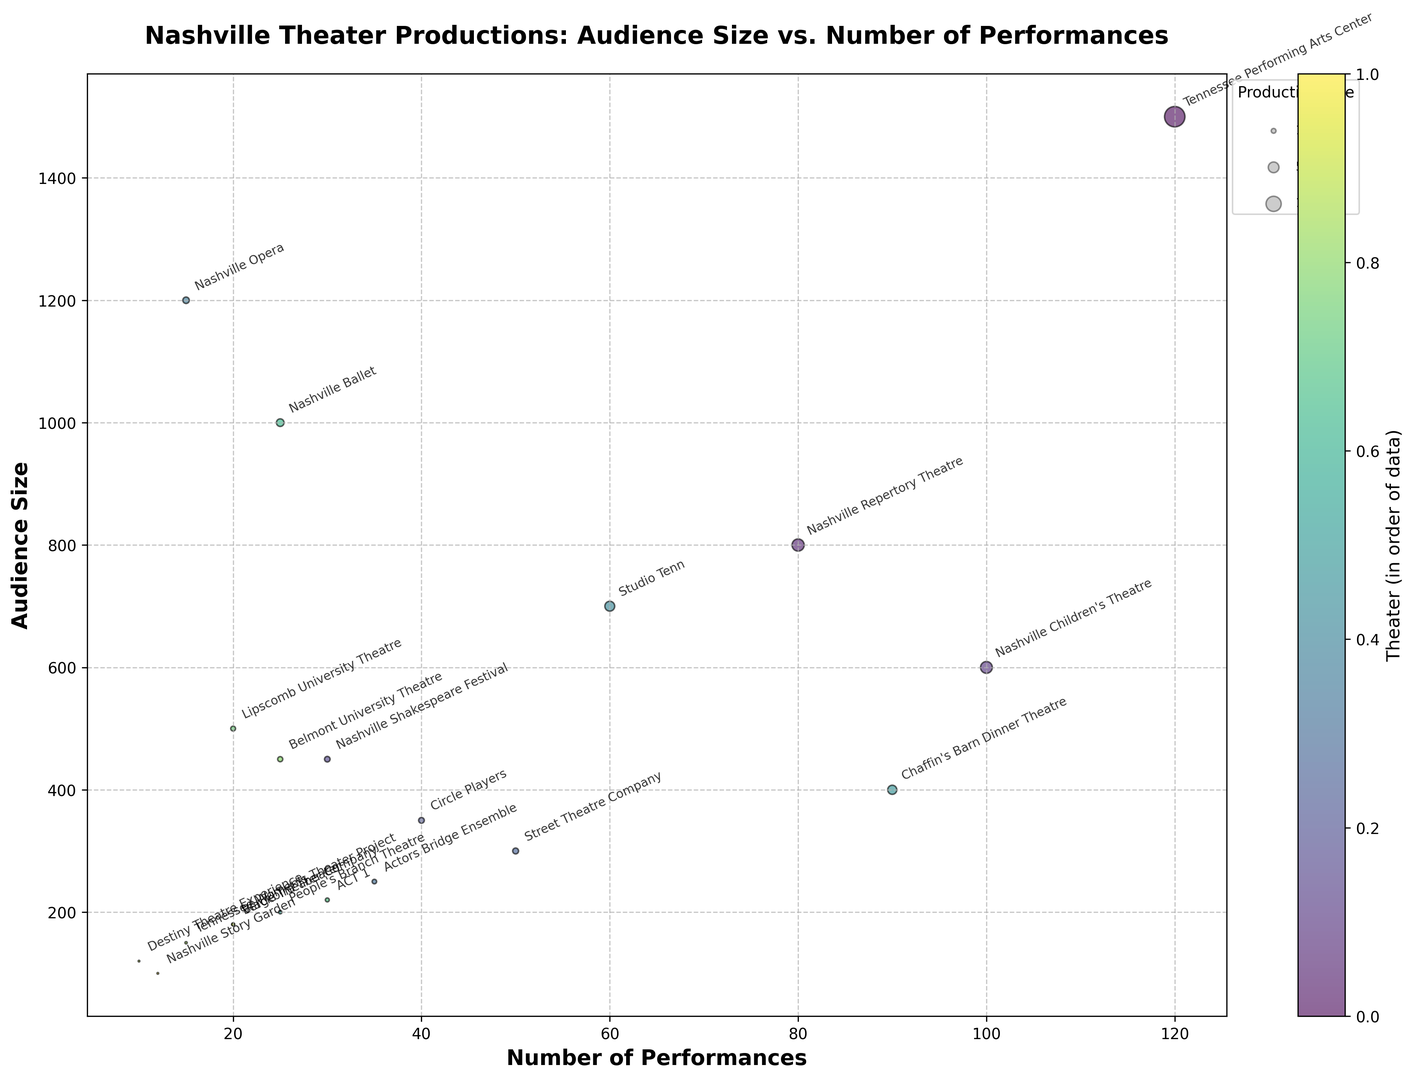What theater has the highest number of performances? The number of performances is represented on the x-axis. The Tennessee Performing Arts Center is farthest on the right, indicating it has the highest number of performances.
Answer: Tennessee Performing Arts Center Which theater has the largest audience size? The audience size is represented on the y-axis. The Tennessee Performing Arts Center is the highest point along the y-axis, indicating it has the largest audience size.
Answer: Tennessee Performing Arts Center What theater has the smallest bubble size and how many performances does it have? The bubble size represents the combined effect of audience size and number of performances. Nashville Story Garden has the smallest bubble and it lies at around 12 on the x-axis, which represents the number of performances.
Answer: Nashville Story Garden, 12 performances Which has a larger audience size: Nashville Repertory Theatre or Studio Tenn? Comparing their y-axis positions, Nashville Repertory Theatre is higher than Studio Tenn, indicating Nashville Repertory Theatre has a larger audience size.
Answer: Nashville Repertory Theatre Which theater has a higher combination of audience size and number of performances between Nashville Ballet and Nashville Opera? Comparing the bubble sizes, Nashville Ballet has a larger bubble than Nashville Opera, indicating a higher combination of audience size and number of performances.
Answer: Nashville Ballet How many theaters have an audience size greater than 500 and less than 1000? Looking at the y-axis and identifying bubbles between 500 and 1000: Nashville Repertory Theatre, Nashville Children's Theatre, and Studio Tenn.
Answer: 3 theaters Which theater has more performances: Lipscomb University Theatre or Belmont University Theatre? Comparing their x-axis positions, Lipscomb University Theatre is further to the left than Belmont University Theatre, indicating Belmont University Theatre has more performances.
Answer: Belmont University Theatre What is the combined audience size of Tennessee Performing Arts Center and Nashville Opera? Tennessee Performing Arts Center has 1500 and Nashville Opera has 1200. Adding them together, 1500 + 1200 = 2700.
Answer: 2700 Which has more performances: Chaffin's Barn Dinner Theatre or Nashville Children's Theatre? Comparing their x-axis positions, Nashville Children's Theatre is further to the right than Chaffin's Barn Dinner Theatre, indicating Nashville Children's Theatre has more performances.
Answer: Nashville Children's Theatre Which theater has the least combination of audience size and number of performances, except Nashville Story Garden? Looking at bubble sizes, Destiny Theatre Experience has the smallest bubble after Nashville Story Garden.
Answer: Destiny Theatre Experience 